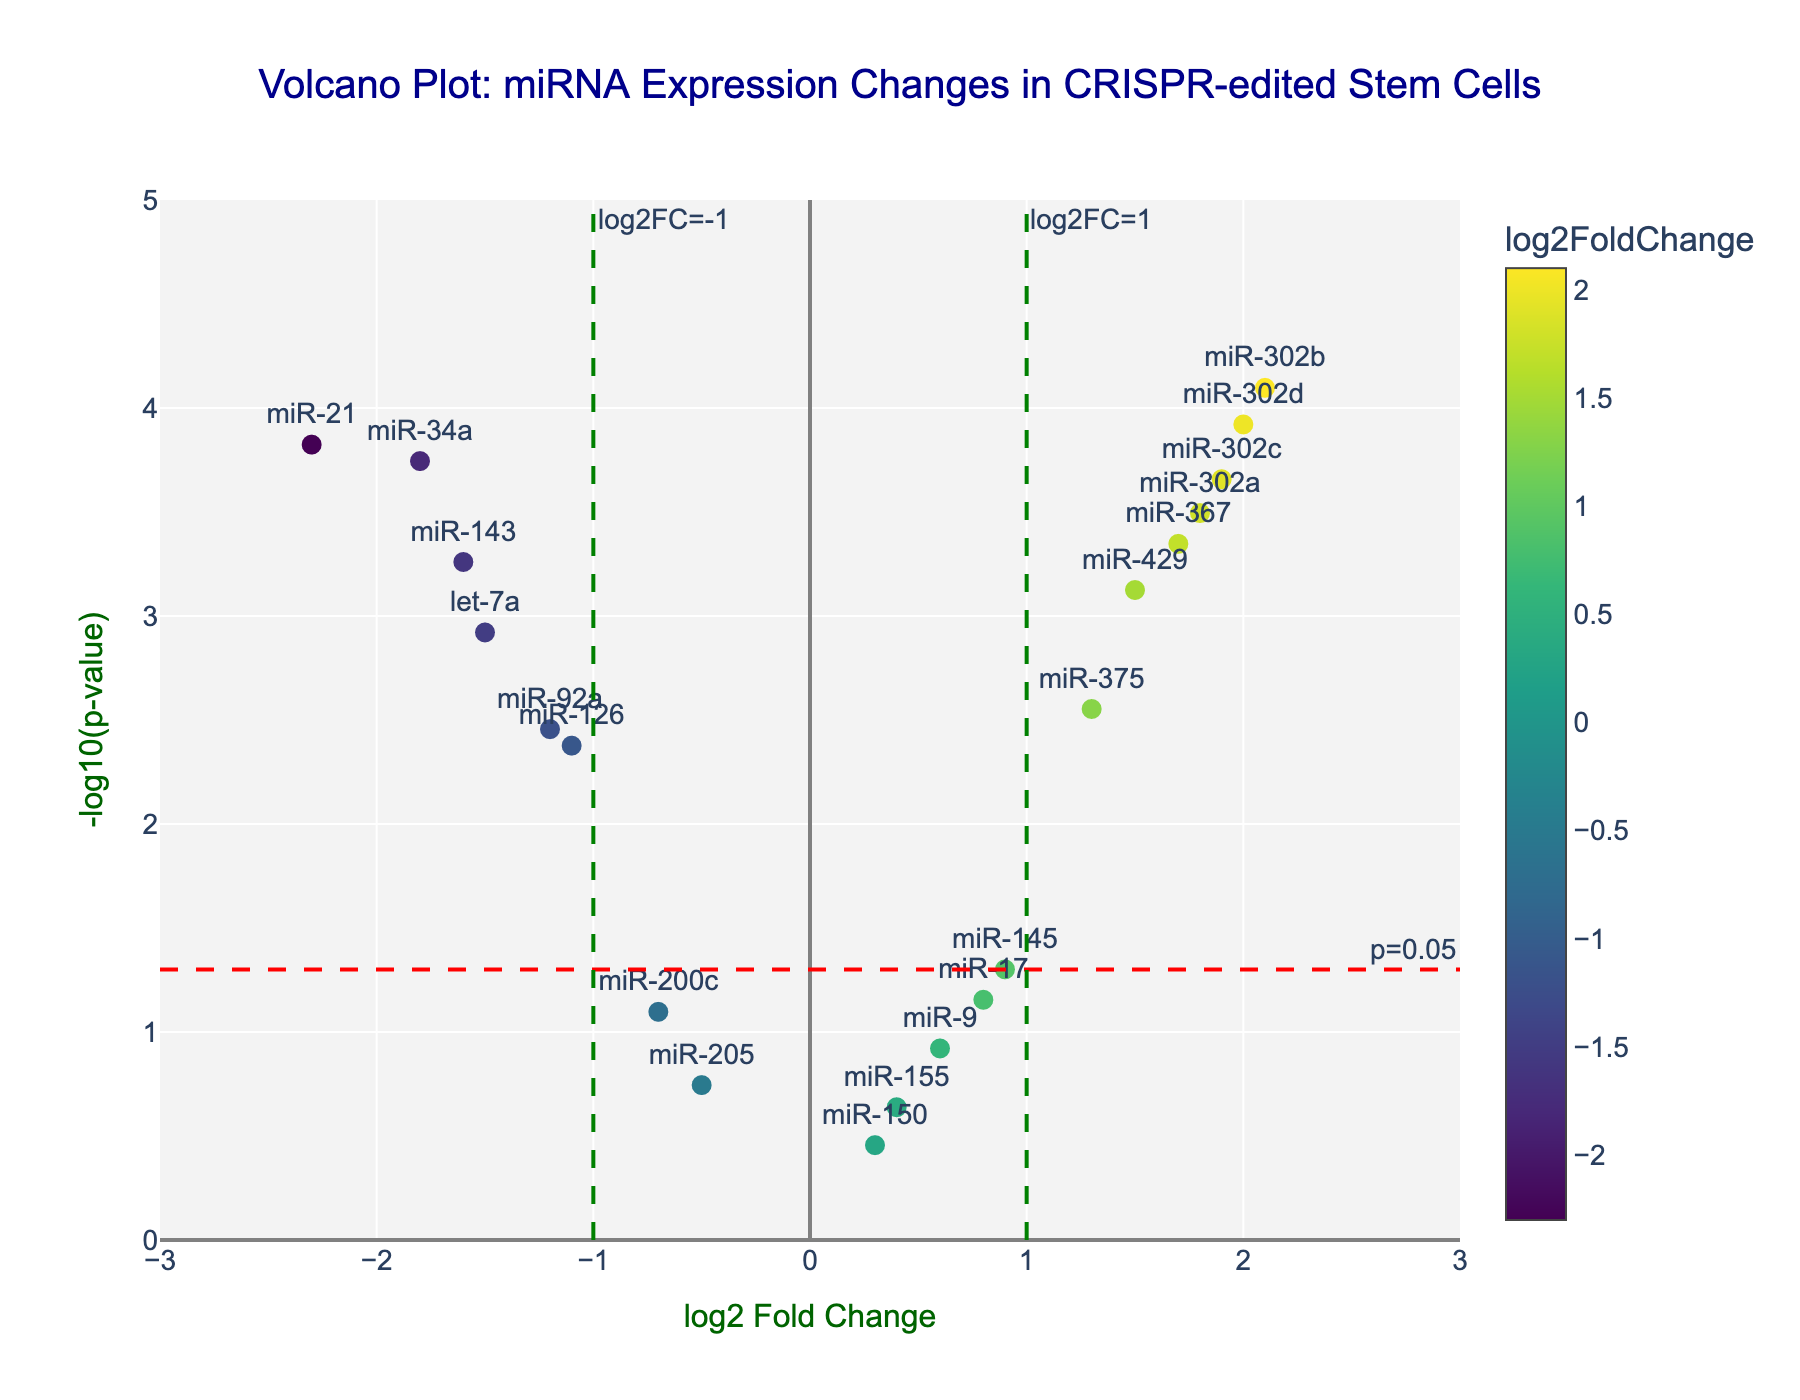Which miRNA has the highest -log10(p-value)? To find this, look at the y-axis and identify the miRNA with the highest point. In this plot, it's miR-302b.
Answer: miR-302b How many miRNAs have a -log10(p-value) greater than 2? Look along the y-axis for the points above 2. There are several points above 2, precisely 6 of them (miR-21, miR-302a, miR-302b, miR-302c, miR-34a, miR-302d).
Answer: 6 Which miRNA has the highest log2 Fold Change? Look at the x-axis and identify the rightmost point. The highest log2 Fold Change belongs to miR-302b.
Answer: miR-302b Compare miR-21 and let-7a: Which one has a lower p-value? For a lower p-value, the point must be higher on the y-axis (-log10(p-value)). miR-21 corresponds to a point higher than let-7a.
Answer: miR-21 How many miRNAs have both log2 Fold Change greater than 1 and p-value less than 0.05? First, identify miRNAs with log2 Fold Change > 1, then check if their y-axis value is above the -log10(0.05) threshold, which is 1.3. The miRNAs are miR-302a, miR-302b, miR-302c, miR-302d, miR-367, and miR-429.
Answer: 6 Which miRNA has the lowest -log10(p-value)? Look for the miRNA with the lowest point along the y-axis. miR-150 has the lowest -log10(p-value).
Answer: miR-150 How many miRNAs show significant downregulation with p-value < 0.05? Significant downregulation means log2 Fold Change < -1 and p-value < 0.05. The miRNAs that satisfy this condition are miR-21, let-7a, miR-34a, and miR-143.
Answer: 4 Compare miR-145 and miR-17: Which one is closer to zero log2 Fold Change? The closer location to zero log2 Fold Change refers to proximity to the x-axis line x=0. miR-145 is closer to zero than miR-17.
Answer: miR-145 